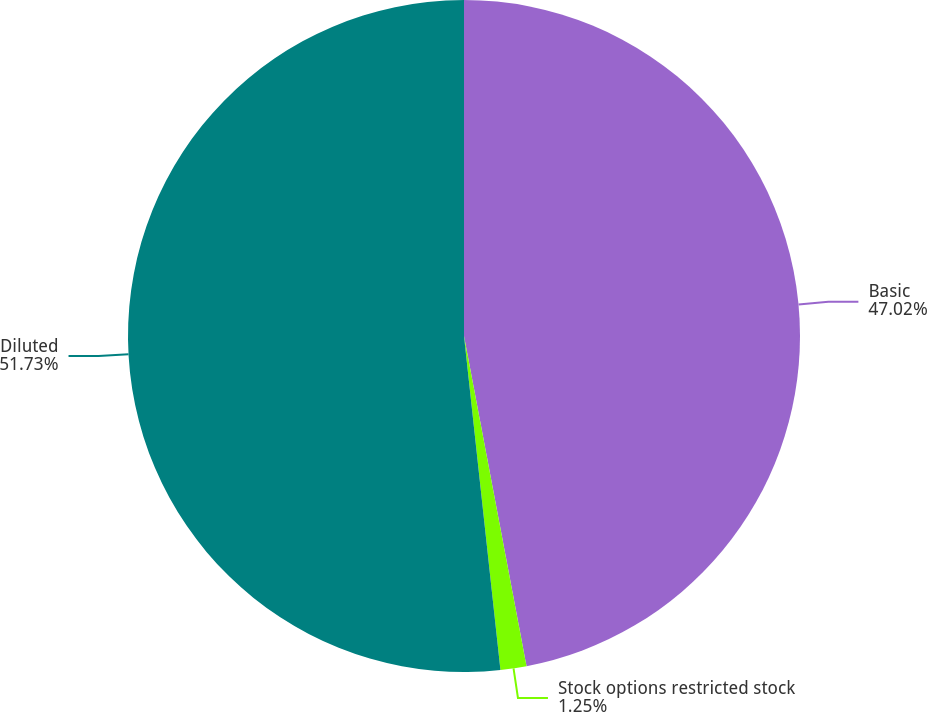<chart> <loc_0><loc_0><loc_500><loc_500><pie_chart><fcel>Basic<fcel>Stock options restricted stock<fcel>Diluted<nl><fcel>47.02%<fcel>1.25%<fcel>51.73%<nl></chart> 